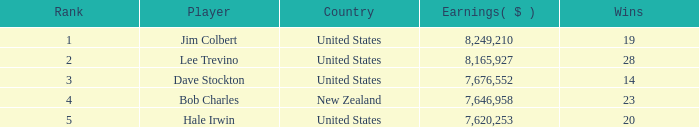How many players named bob charles possess earnings above $7,646,958? 0.0. 